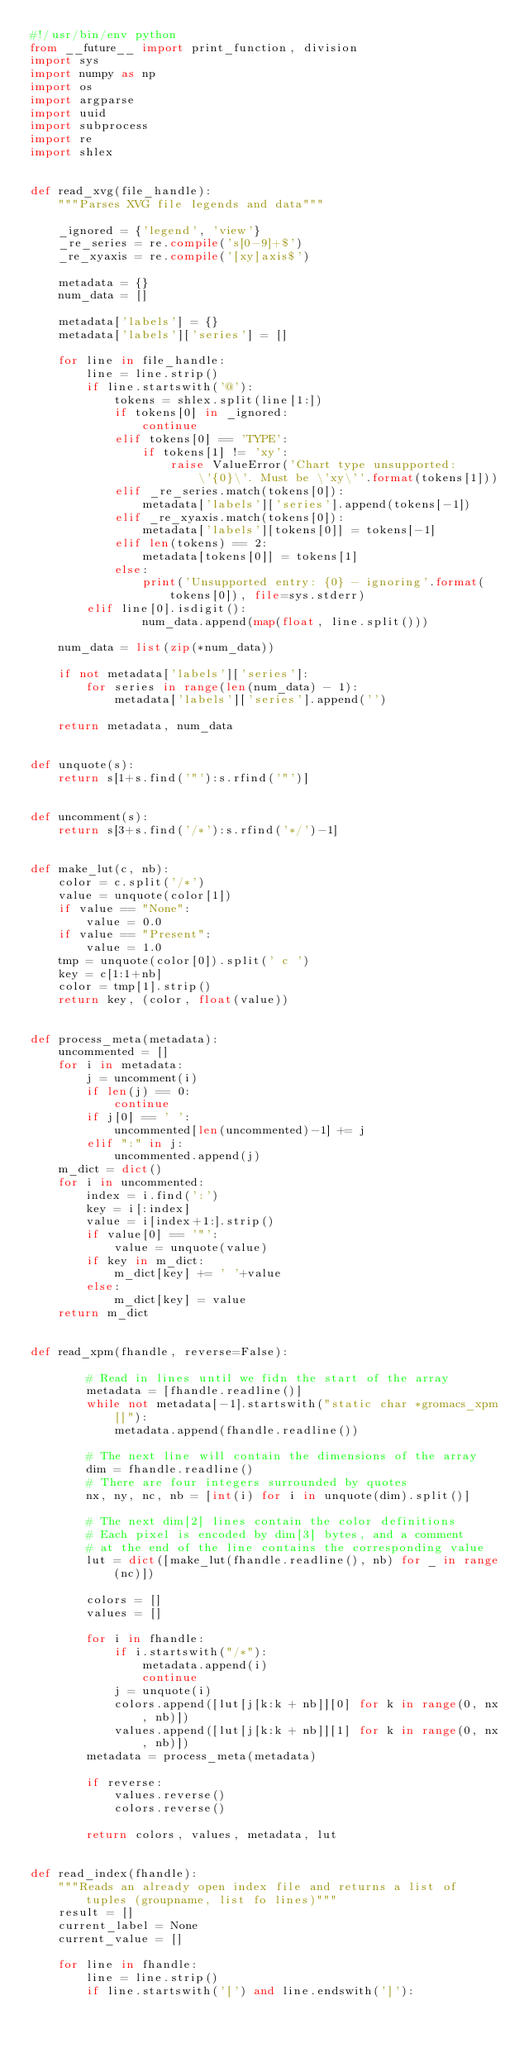<code> <loc_0><loc_0><loc_500><loc_500><_Python_>#!/usr/bin/env python
from __future__ import print_function, division
import sys
import numpy as np
import os
import argparse
import uuid
import subprocess
import re
import shlex


def read_xvg(file_handle):
    """Parses XVG file legends and data"""

    _ignored = {'legend', 'view'}
    _re_series = re.compile('s[0-9]+$')
    _re_xyaxis = re.compile('[xy]axis$')

    metadata = {}
    num_data = []

    metadata['labels'] = {}
    metadata['labels']['series'] = []

    for line in file_handle:
        line = line.strip()
        if line.startswith('@'):
            tokens = shlex.split(line[1:])
            if tokens[0] in _ignored:
                continue
            elif tokens[0] == 'TYPE':
                if tokens[1] != 'xy':
                    raise ValueError('Chart type unsupported: \'{0}\'. Must be \'xy\''.format(tokens[1]))
            elif _re_series.match(tokens[0]):
                metadata['labels']['series'].append(tokens[-1])
            elif _re_xyaxis.match(tokens[0]):
                metadata['labels'][tokens[0]] = tokens[-1]
            elif len(tokens) == 2:
                metadata[tokens[0]] = tokens[1]
            else:
                print('Unsupported entry: {0} - ignoring'.format(tokens[0]), file=sys.stderr)
        elif line[0].isdigit():
                num_data.append(map(float, line.split()))

    num_data = list(zip(*num_data))

    if not metadata['labels']['series']:
        for series in range(len(num_data) - 1):
            metadata['labels']['series'].append('')

    return metadata, num_data


def unquote(s):
    return s[1+s.find('"'):s.rfind('"')]


def uncomment(s):
    return s[3+s.find('/*'):s.rfind('*/')-1]


def make_lut(c, nb):
    color = c.split('/*')
    value = unquote(color[1])
    if value == "None":
        value = 0.0
    if value == "Present":
        value = 1.0
    tmp = unquote(color[0]).split(' c ')
    key = c[1:1+nb]
    color = tmp[1].strip()
    return key, (color, float(value))


def process_meta(metadata):
    uncommented = []
    for i in metadata:
        j = uncomment(i)
        if len(j) == 0:
            continue
        if j[0] == ' ':
            uncommented[len(uncommented)-1] += j
        elif ":" in j:
            uncommented.append(j)
    m_dict = dict()
    for i in uncommented:
        index = i.find(':')
        key = i[:index]
        value = i[index+1:].strip()
        if value[0] == '"':
            value = unquote(value)
        if key in m_dict:
            m_dict[key] += ' '+value
        else:
            m_dict[key] = value
    return m_dict


def read_xpm(fhandle, reverse=False):

        # Read in lines until we fidn the start of the array
        metadata = [fhandle.readline()]
        while not metadata[-1].startswith("static char *gromacs_xpm[]"):
            metadata.append(fhandle.readline())

        # The next line will contain the dimensions of the array
        dim = fhandle.readline()
        # There are four integers surrounded by quotes
        nx, ny, nc, nb = [int(i) for i in unquote(dim).split()]

        # The next dim[2] lines contain the color definitions
        # Each pixel is encoded by dim[3] bytes, and a comment
        # at the end of the line contains the corresponding value
        lut = dict([make_lut(fhandle.readline(), nb) for _ in range(nc)])

        colors = []
        values = []

        for i in fhandle:
            if i.startswith("/*"):
                metadata.append(i)
                continue
            j = unquote(i)
            colors.append([lut[j[k:k + nb]][0] for k in range(0, nx, nb)])
            values.append([lut[j[k:k + nb]][1] for k in range(0, nx, nb)])
        metadata = process_meta(metadata)

        if reverse:
            values.reverse()
            colors.reverse()

        return colors, values, metadata, lut


def read_index(fhandle):
    """Reads an already open index file and returns a list of tuples (groupname, list fo lines)"""
    result = []
    current_label = None
    current_value = []

    for line in fhandle:
        line = line.strip()
        if line.startswith('[') and line.endswith(']'):</code> 